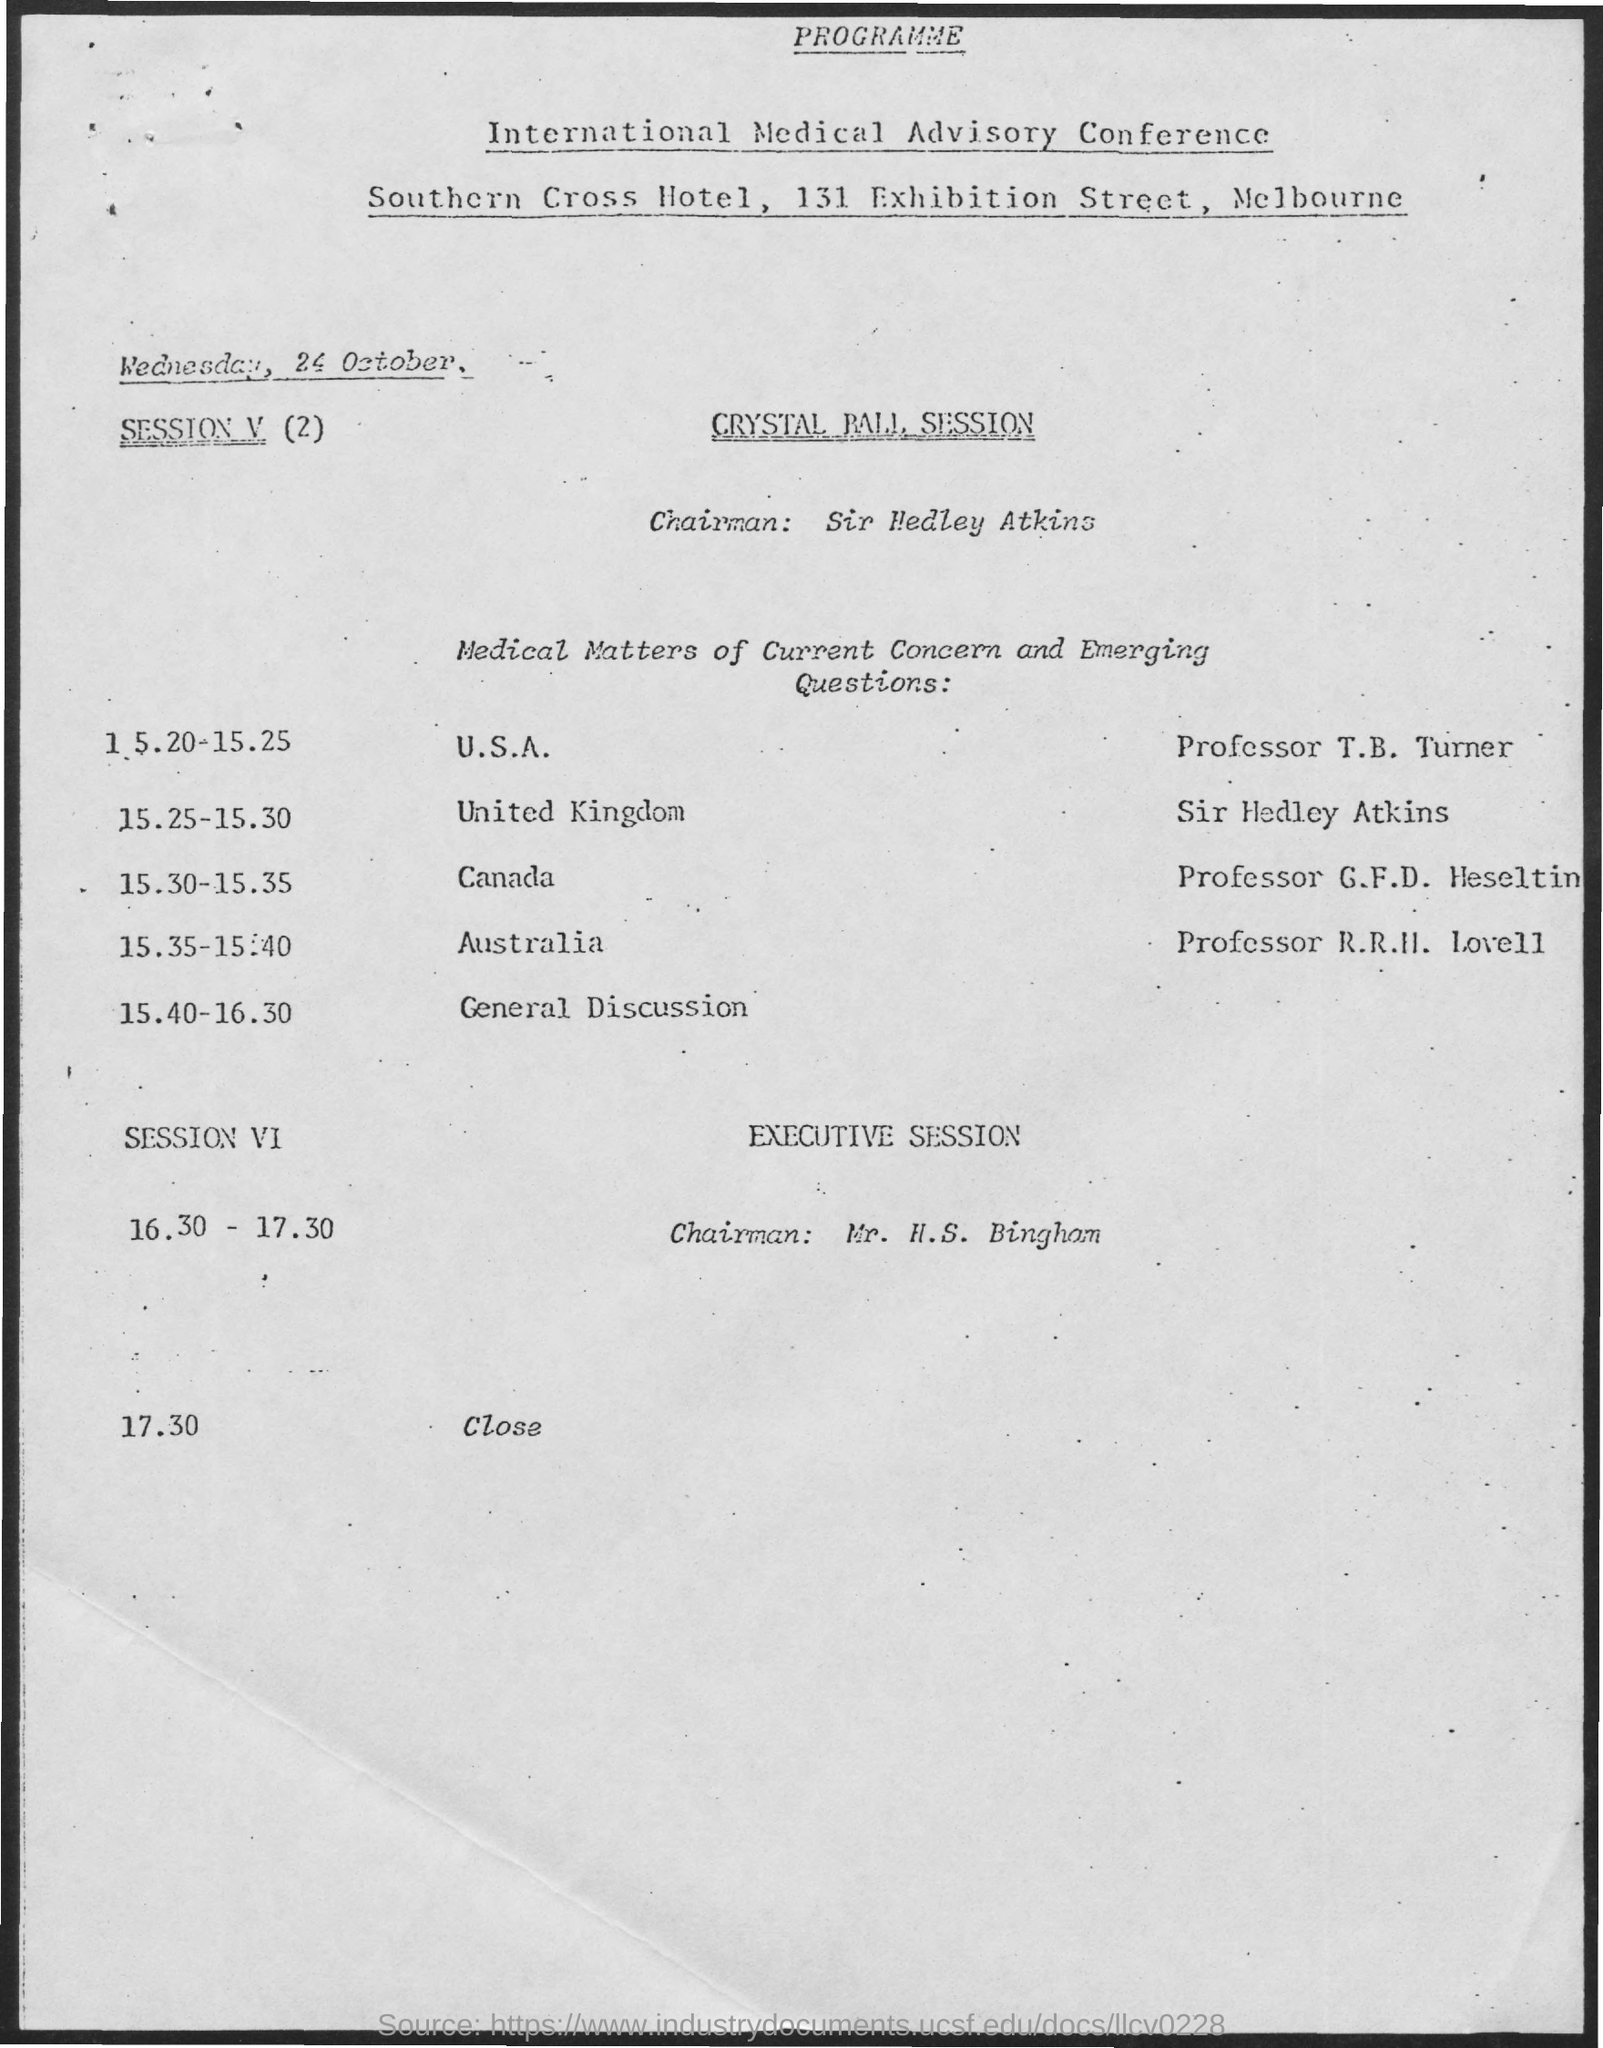Mention a couple of crucial points in this snapshot. The chairman of Crystal Palace is Sir Hedley Atkins. At 15:25-15:30, the session is taken by Sir Hedley Atkins. The session will be closed at 17:30. The date mentioned is Wednesday, October 24. The venue for the Sir Hedley Atkins Session is located in the United Kingdom. 